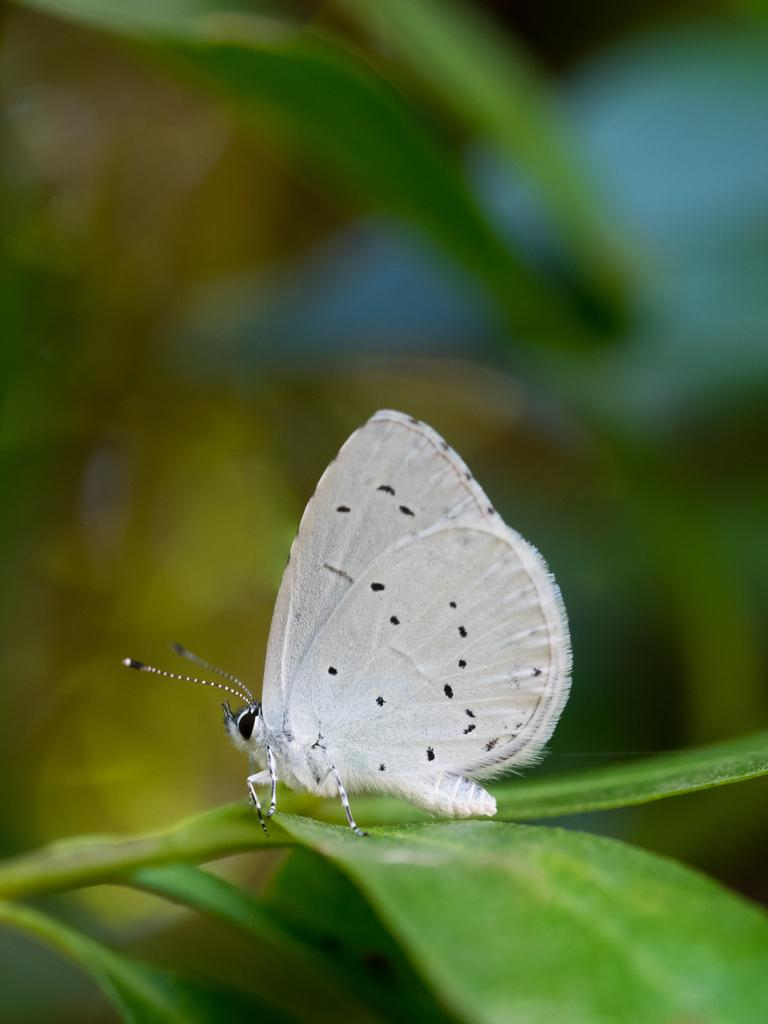What type of animal can be seen in the image? There is a white butterfly in the image. Where is the butterfly located? The butterfly is sitting on a plant. Can you describe the plant the butterfly is sitting on? Unfortunately, the plant is not clearly visible in the image. Are there any other plants visible in the image? Yes, there are other plants visible in the background, but they are not clearly visible. What type of mark can be seen on the butterfly's wings in the image? There is no mark visible on the butterfly's wings in the image. How many planes are flying in the background of the image? There are no planes visible in the image; it features a white butterfly sitting on a plant. 